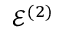<formula> <loc_0><loc_0><loc_500><loc_500>\mathcal { E } ^ { ( 2 ) }</formula> 